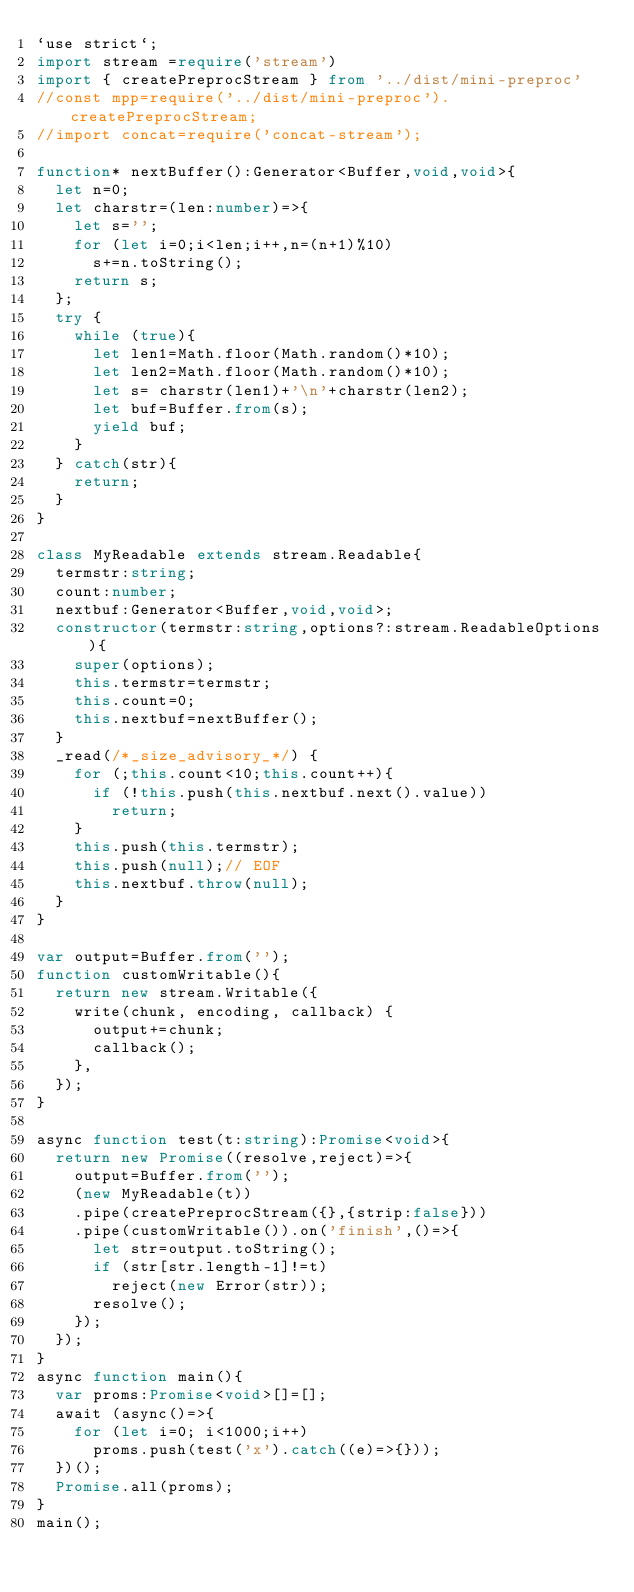<code> <loc_0><loc_0><loc_500><loc_500><_TypeScript_>`use strict`;
import stream =require('stream')
import { createPreprocStream } from '../dist/mini-preproc'
//const mpp=require('../dist/mini-preproc').createPreprocStream;
//import concat=require('concat-stream');

function* nextBuffer():Generator<Buffer,void,void>{
  let n=0;
  let charstr=(len:number)=>{
    let s='';
    for (let i=0;i<len;i++,n=(n+1)%10)
      s+=n.toString();
    return s;
  }; 
  try {
    while (true){
      let len1=Math.floor(Math.random()*10);
      let len2=Math.floor(Math.random()*10);
      let s= charstr(len1)+'\n'+charstr(len2);
      let buf=Buffer.from(s);
      yield buf; 
    }
  } catch(str){
    return;
  }
}

class MyReadable extends stream.Readable{
  termstr:string;
  count:number;
  nextbuf:Generator<Buffer,void,void>;
  constructor(termstr:string,options?:stream.ReadableOptions){
    super(options);
    this.termstr=termstr;
    this.count=0;
    this.nextbuf=nextBuffer();
  }
  _read(/*_size_advisory_*/) {
    for (;this.count<10;this.count++){
      if (!this.push(this.nextbuf.next().value))
        return;
    }
    this.push(this.termstr); 
    this.push(null);// EOF
    this.nextbuf.throw(null);
  }
}

var output=Buffer.from('');
function customWritable(){
  return new stream.Writable({
    write(chunk, encoding, callback) {
      output+=chunk;
      callback();
    },
  });
}

async function test(t:string):Promise<void>{
  return new Promise((resolve,reject)=>{
    output=Buffer.from('');
    (new MyReadable(t))
    .pipe(createPreprocStream({},{strip:false}))
    .pipe(customWritable()).on('finish',()=>{
      let str=output.toString();
      if (str[str.length-1]!=t)
        reject(new Error(str));
      resolve();            
    });
  });
}
async function main(){
  var proms:Promise<void>[]=[];
  await (async()=>{
    for (let i=0; i<1000;i++)
      proms.push(test('x').catch((e)=>{}));
  })();
  Promise.all(proms);
}
main();</code> 